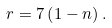Convert formula to latex. <formula><loc_0><loc_0><loc_500><loc_500>r = 7 \left ( 1 - n \right ) .</formula> 